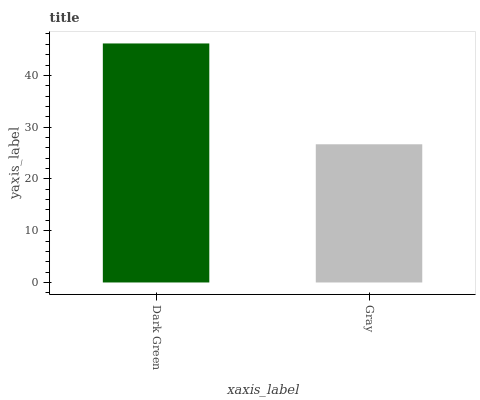Is Gray the maximum?
Answer yes or no. No. Is Dark Green greater than Gray?
Answer yes or no. Yes. Is Gray less than Dark Green?
Answer yes or no. Yes. Is Gray greater than Dark Green?
Answer yes or no. No. Is Dark Green less than Gray?
Answer yes or no. No. Is Dark Green the high median?
Answer yes or no. Yes. Is Gray the low median?
Answer yes or no. Yes. Is Gray the high median?
Answer yes or no. No. Is Dark Green the low median?
Answer yes or no. No. 